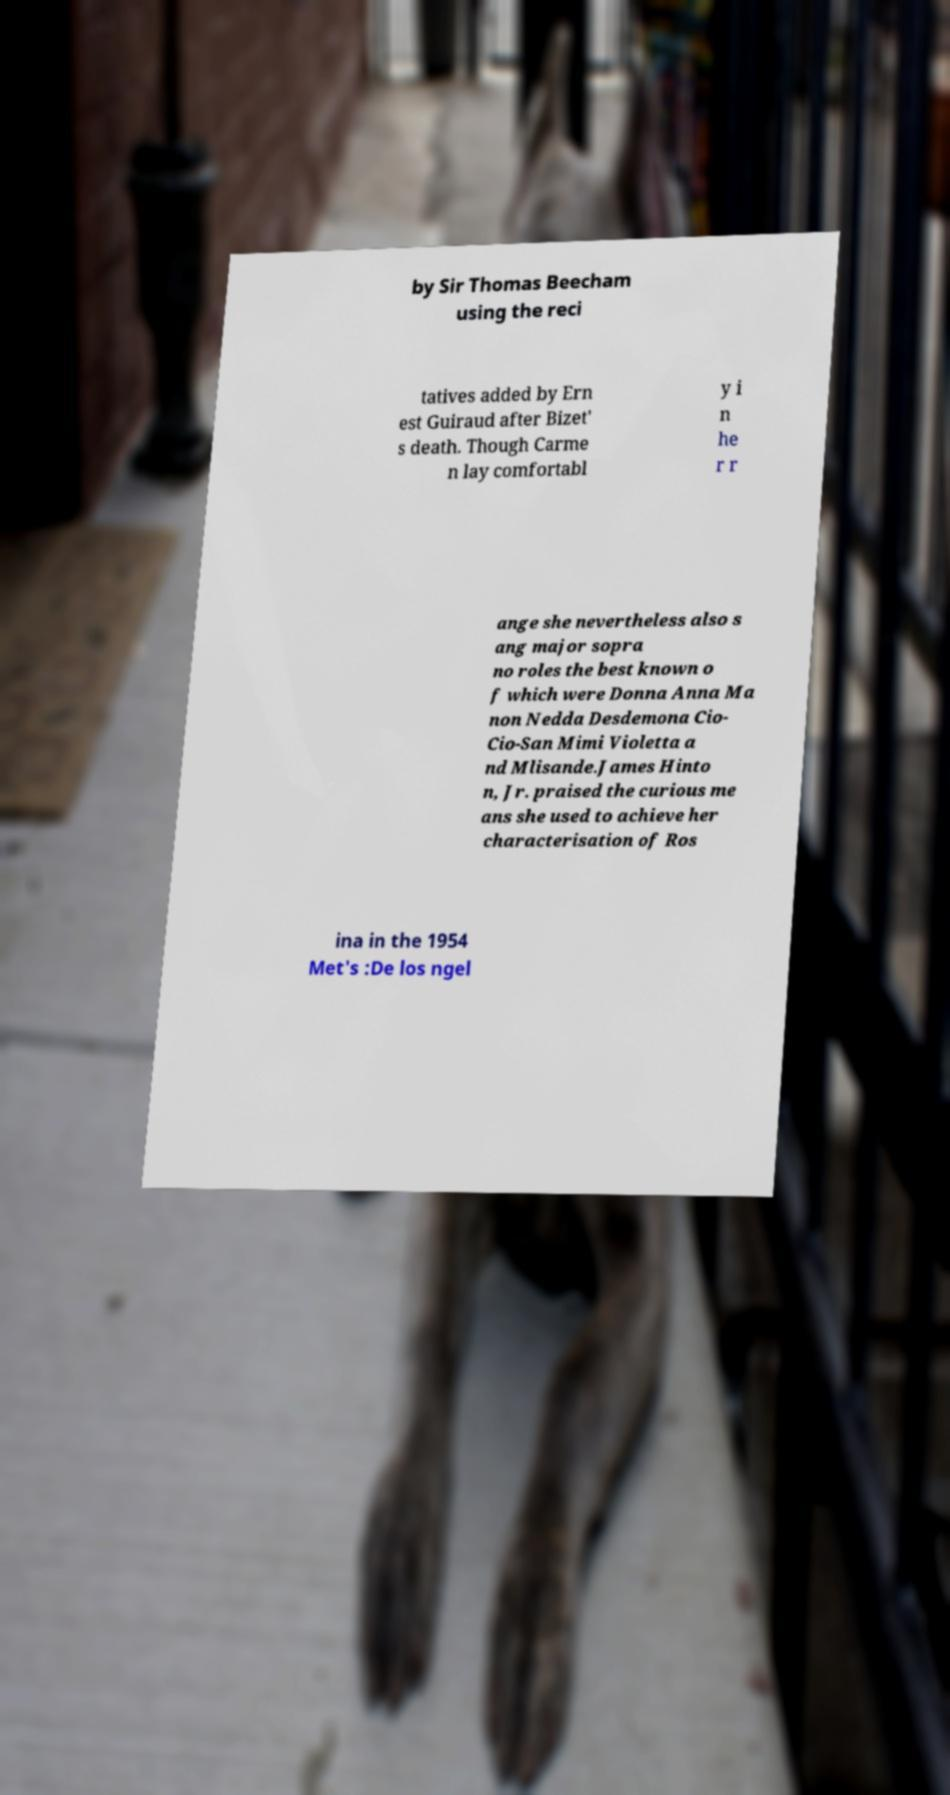Please identify and transcribe the text found in this image. by Sir Thomas Beecham using the reci tatives added by Ern est Guiraud after Bizet' s death. Though Carme n lay comfortabl y i n he r r ange she nevertheless also s ang major sopra no roles the best known o f which were Donna Anna Ma non Nedda Desdemona Cio- Cio-San Mimi Violetta a nd Mlisande.James Hinto n, Jr. praised the curious me ans she used to achieve her characterisation of Ros ina in the 1954 Met's :De los ngel 